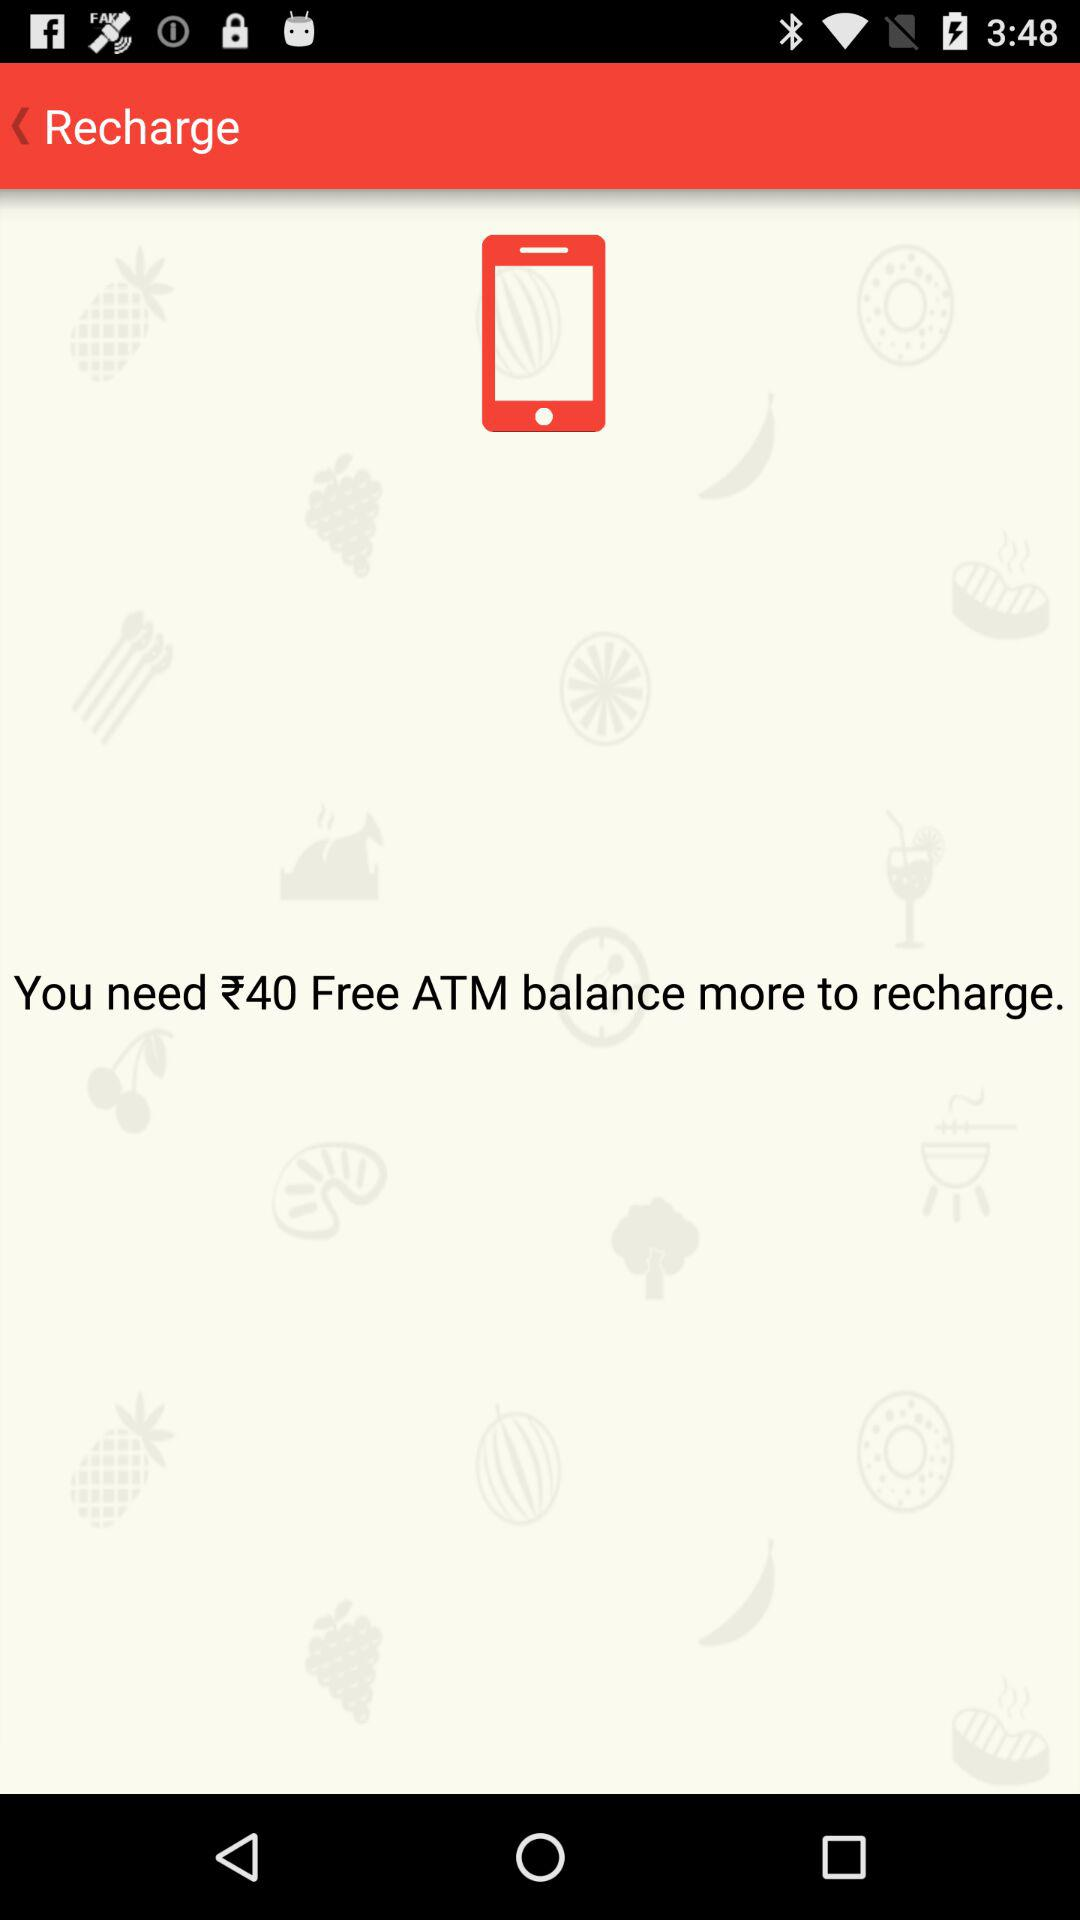How much more of a Free ATM balance do we need for recharge? You need ₹40 Free ATM balance more for recharge. 